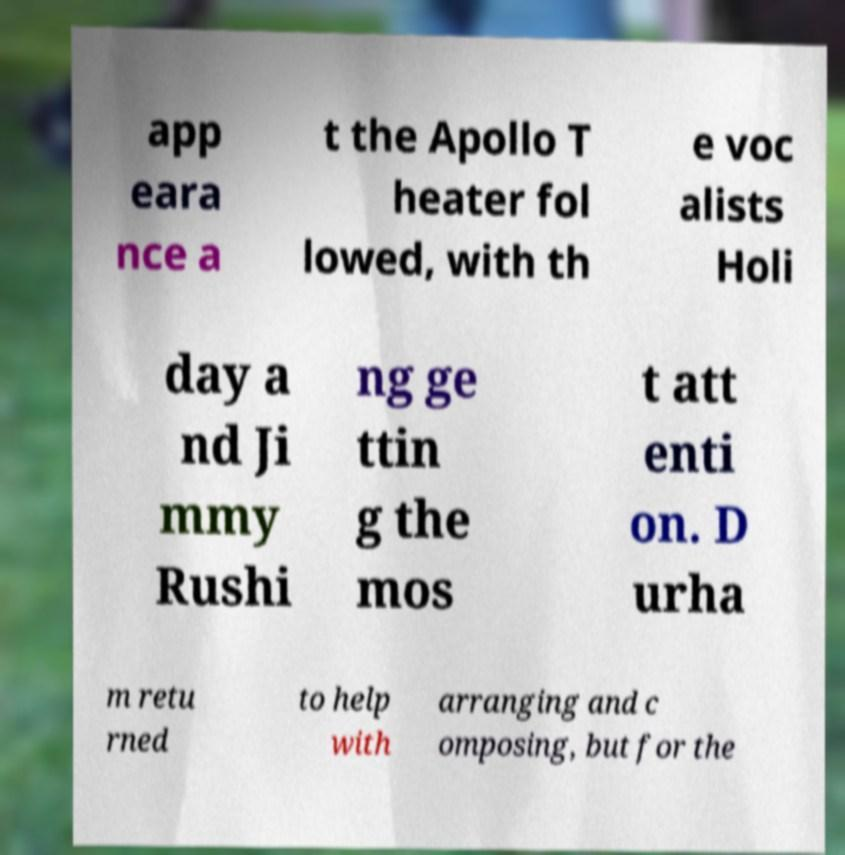Can you accurately transcribe the text from the provided image for me? app eara nce a t the Apollo T heater fol lowed, with th e voc alists Holi day a nd Ji mmy Rushi ng ge ttin g the mos t att enti on. D urha m retu rned to help with arranging and c omposing, but for the 